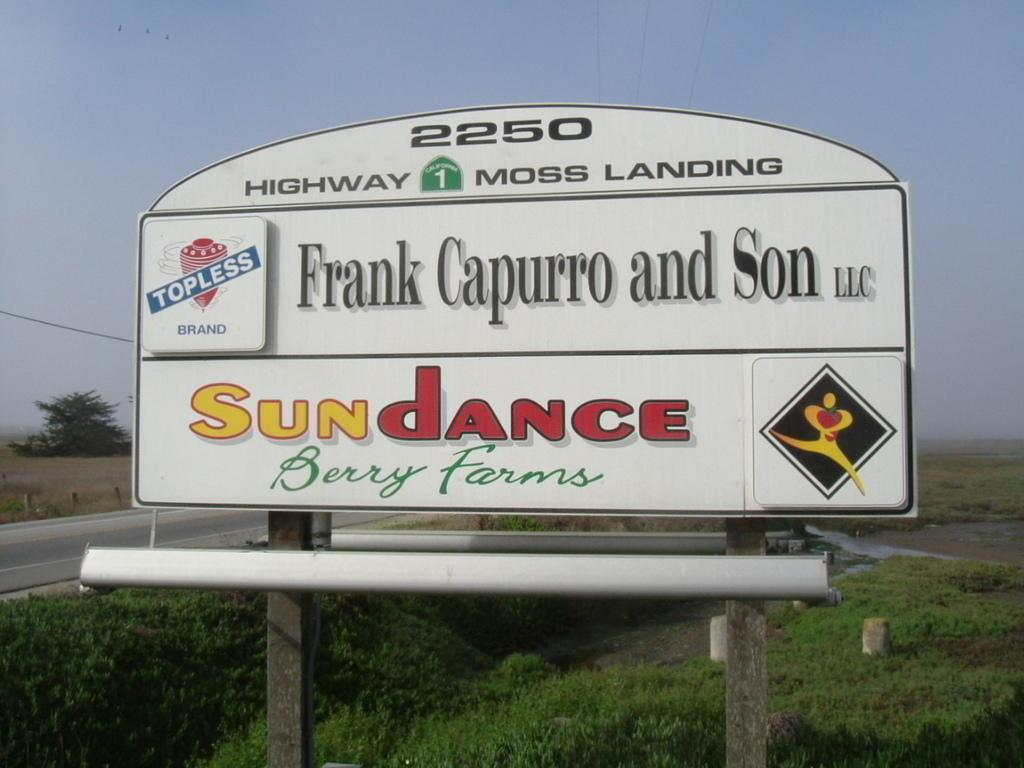Provide a one-sentence caption for the provided image. Road sign for HIghway 1 going to Moss Landing. 